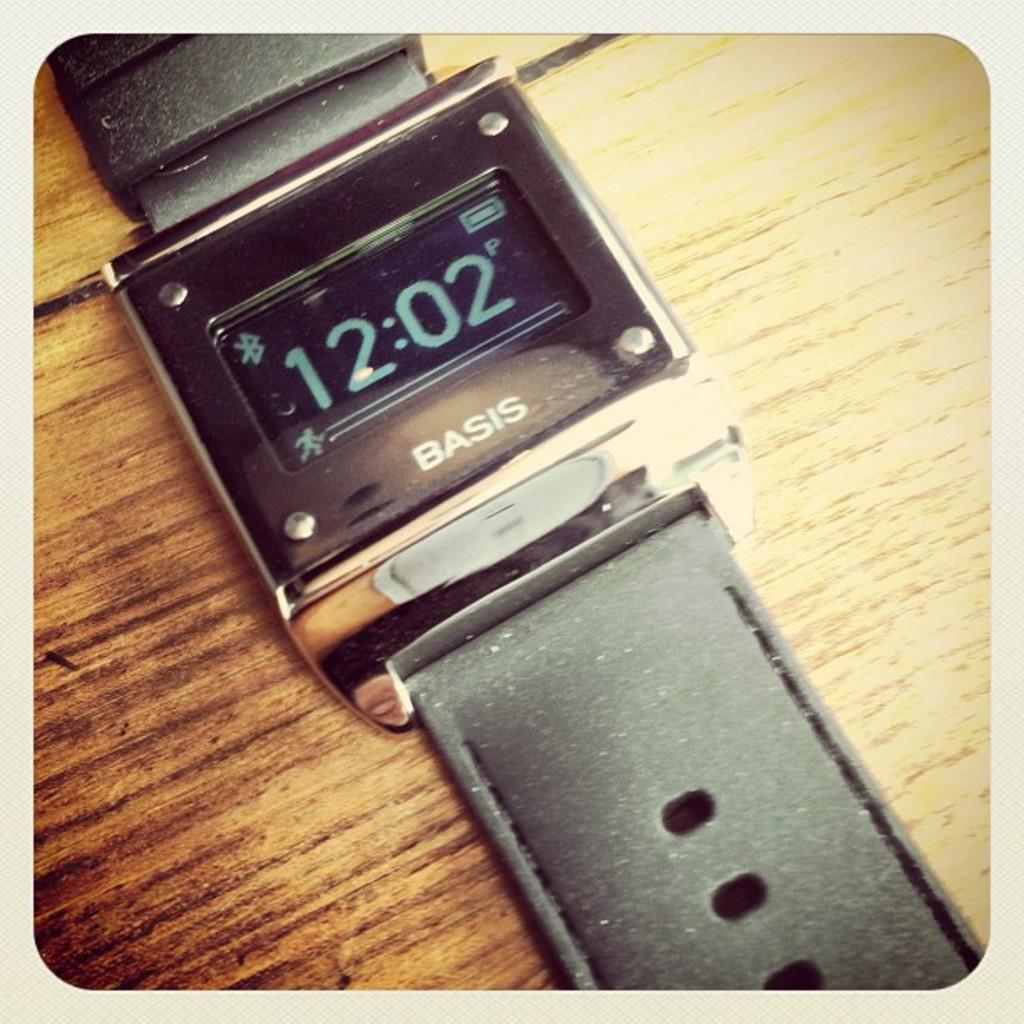What brand is this watch?
Make the answer very short. Basis. What is the time displayed?
Provide a short and direct response. 12:02. 